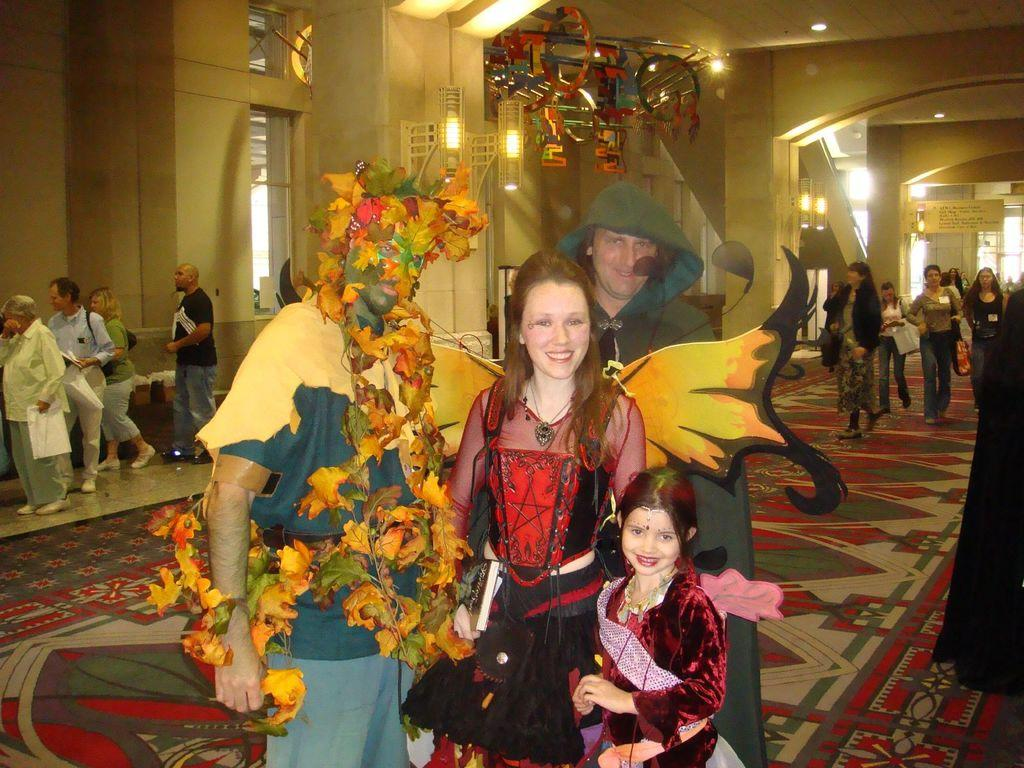How many people are in the image? There are people in the image, but the exact number is not specified. What are some people wearing in the image? Some people are wearing costumes in the image. What type of surface is visible in the image? There is a floor visible in the image. What type of structure is visible in the image? There is a wall visible in the image. What type of openings are visible in the wall? There are windows in the image. What type of illumination is visible in the image? There are lights in the image. What type of writing surface is visible in the image? There is a board in the image. What type of decorative items are visible in the image? There are decorative objects in the image. How many sisters are in the image? The provided facts do not mention any sisters, so we cannot determine the number of sisters in the image. 